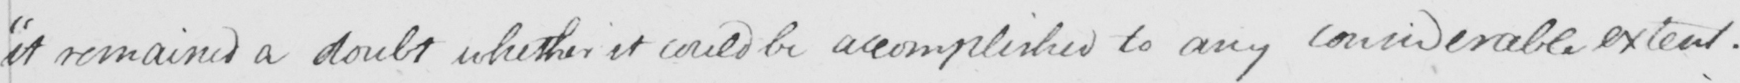Please transcribe the handwritten text in this image. it remained a doubt whether it could be accomplished to any considerable extent . 